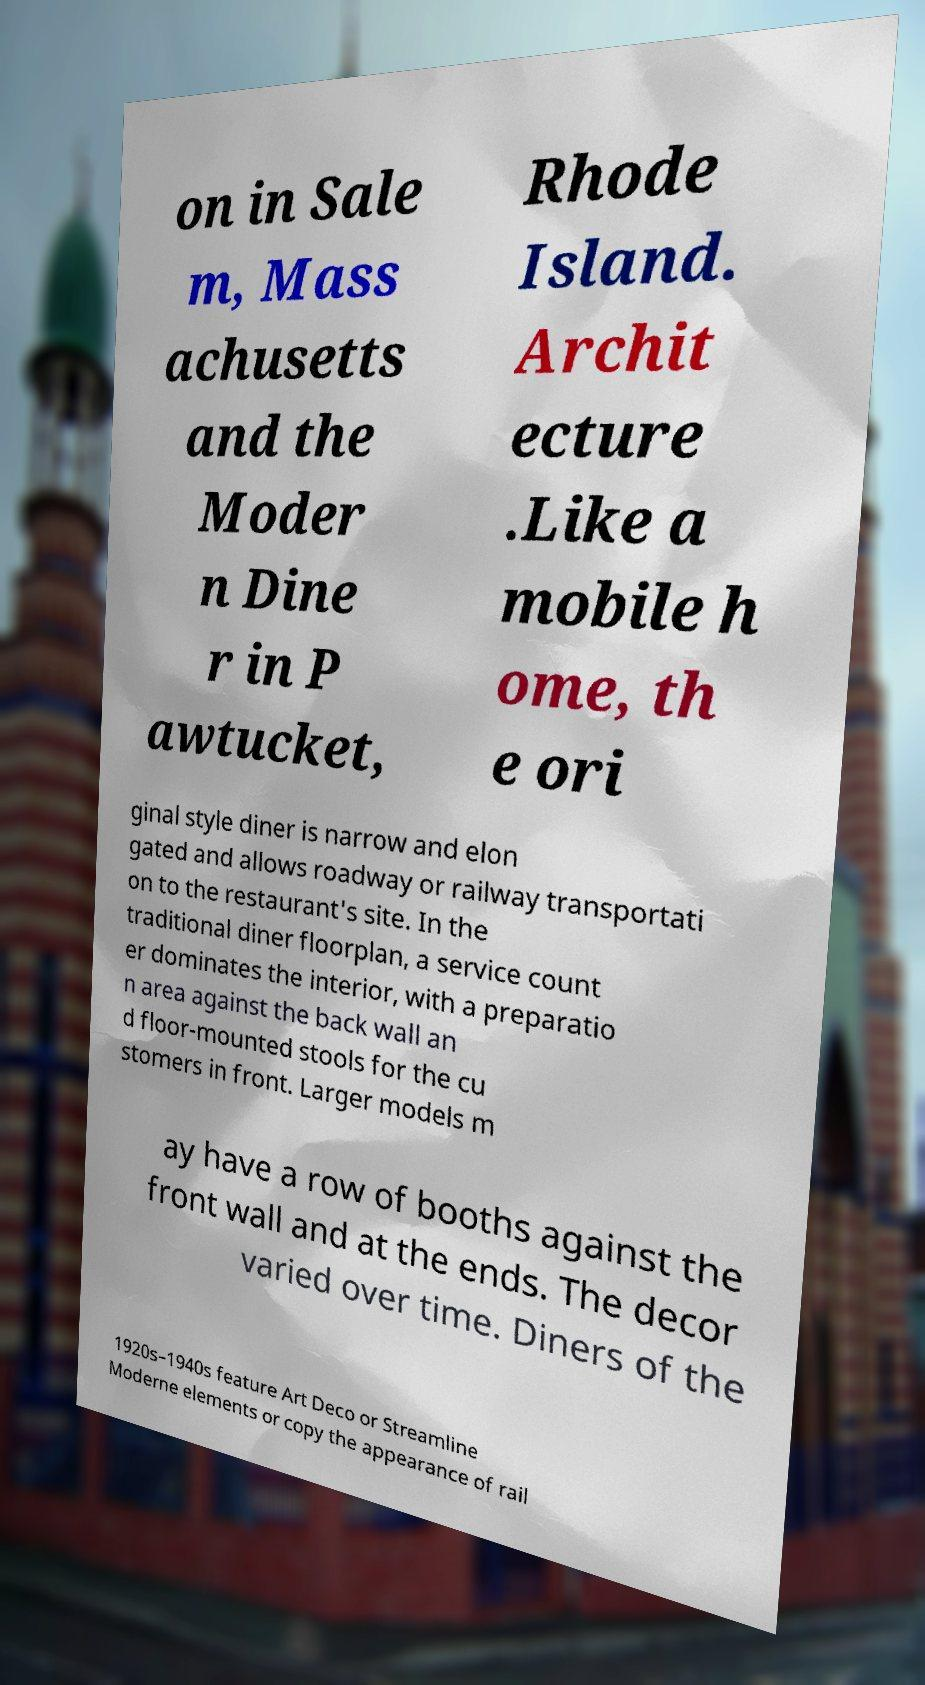I need the written content from this picture converted into text. Can you do that? on in Sale m, Mass achusetts and the Moder n Dine r in P awtucket, Rhode Island. Archit ecture .Like a mobile h ome, th e ori ginal style diner is narrow and elon gated and allows roadway or railway transportati on to the restaurant's site. In the traditional diner floorplan, a service count er dominates the interior, with a preparatio n area against the back wall an d floor-mounted stools for the cu stomers in front. Larger models m ay have a row of booths against the front wall and at the ends. The decor varied over time. Diners of the 1920s–1940s feature Art Deco or Streamline Moderne elements or copy the appearance of rail 